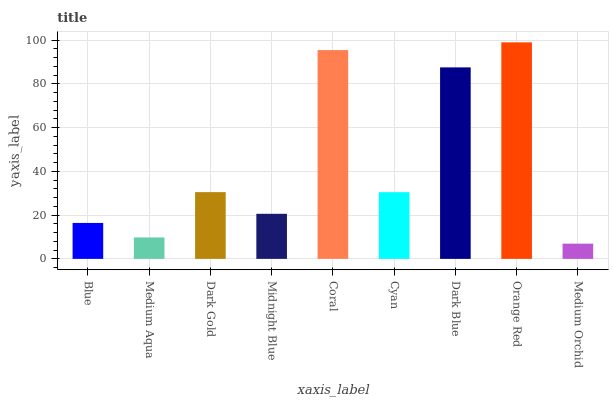Is Medium Orchid the minimum?
Answer yes or no. Yes. Is Orange Red the maximum?
Answer yes or no. Yes. Is Medium Aqua the minimum?
Answer yes or no. No. Is Medium Aqua the maximum?
Answer yes or no. No. Is Blue greater than Medium Aqua?
Answer yes or no. Yes. Is Medium Aqua less than Blue?
Answer yes or no. Yes. Is Medium Aqua greater than Blue?
Answer yes or no. No. Is Blue less than Medium Aqua?
Answer yes or no. No. Is Cyan the high median?
Answer yes or no. Yes. Is Cyan the low median?
Answer yes or no. Yes. Is Dark Gold the high median?
Answer yes or no. No. Is Blue the low median?
Answer yes or no. No. 